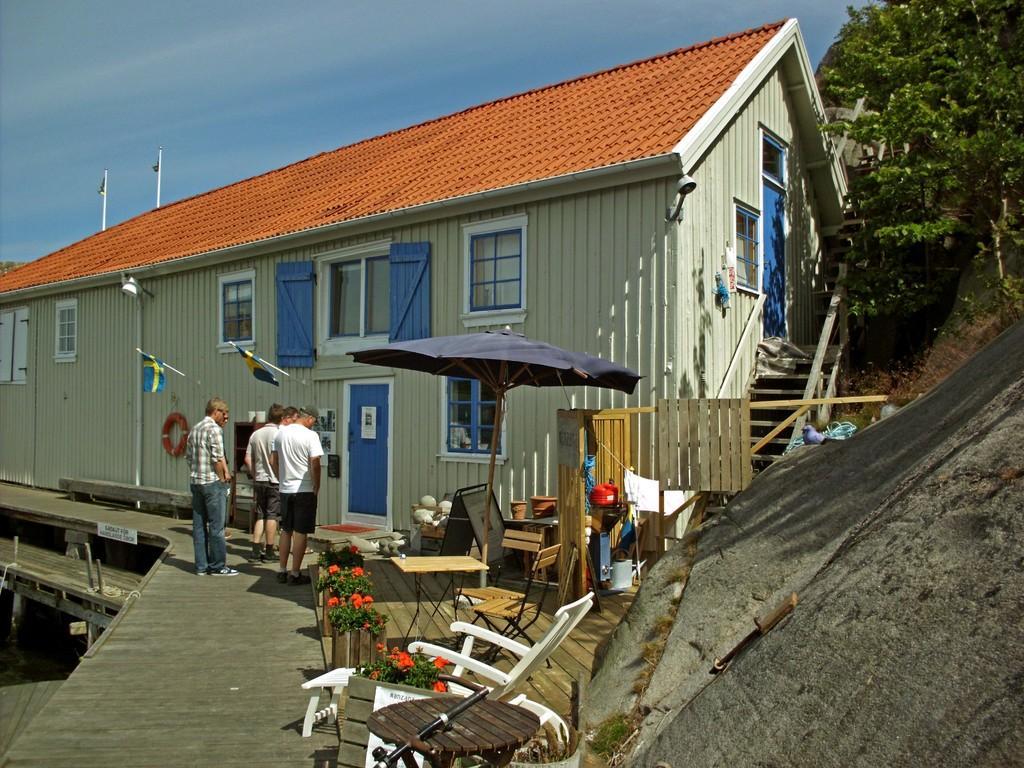Describe this image in one or two sentences. In this image we can see table,chair,flower pot and four members standing. In front there is house and trees. 